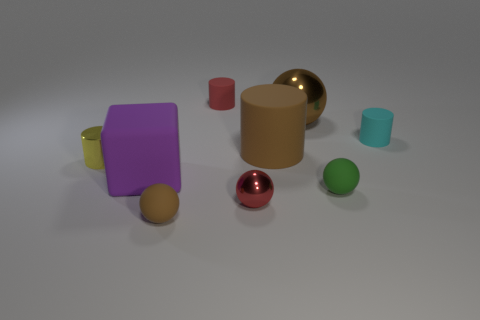Subtract all tiny balls. How many balls are left? 1 Subtract all cyan cylinders. How many cylinders are left? 3 Subtract all blocks. How many objects are left? 8 Subtract 1 cubes. How many cubes are left? 0 Subtract all brown cubes. Subtract all purple cylinders. How many cubes are left? 1 Subtract all brown cylinders. How many green spheres are left? 1 Subtract all tiny red objects. Subtract all big green cubes. How many objects are left? 7 Add 3 large metal balls. How many large metal balls are left? 4 Add 7 small metal things. How many small metal things exist? 9 Subtract 1 purple blocks. How many objects are left? 8 